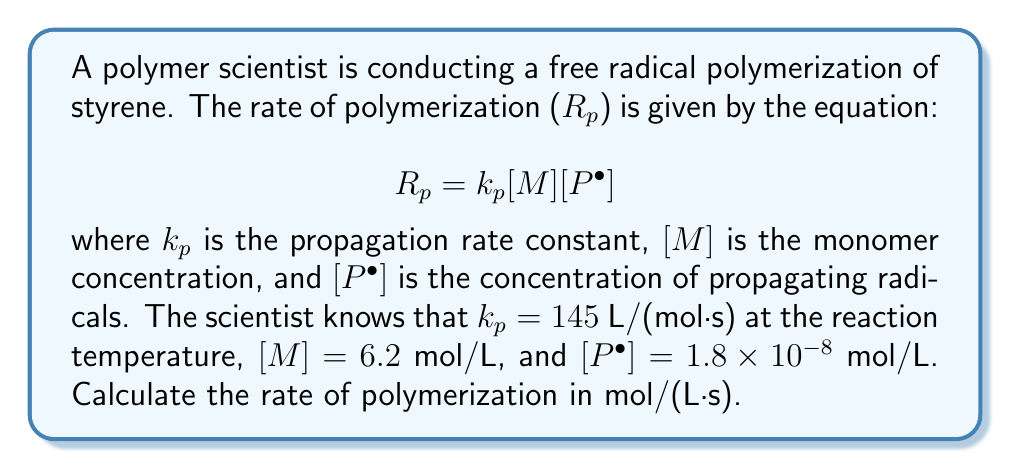Solve this math problem. To solve this problem, we'll follow these steps:

1. Identify the given values:
   $k_p = 145$ L/(mol·s)
   $[M] = 6.2$ mol/L
   $[P^\bullet] = 1.8 \times 10^{-8}$ mol/L

2. Substitute these values into the rate equation:
   $$R_p = k_p[M][P^\bullet]$$
   $$R_p = (145 \text{ L/(mol·s)})(6.2 \text{ mol/L})(1.8 \times 10^{-8} \text{ mol/L})$$

3. Multiply the values:
   $$R_p = 145 \times 6.2 \times 1.8 \times 10^{-8}$$
   $$R_p = 1.6184 \times 10^{-5} \text{ mol/(L·s)}$$

4. Round to three significant figures:
   $$R_p = 1.62 \times 10^{-5} \text{ mol/(L·s)}$$

The rate of polymerization is $1.62 \times 10^{-5}$ mol/(L·s).
Answer: $1.62 \times 10^{-5}$ mol/(L·s) 